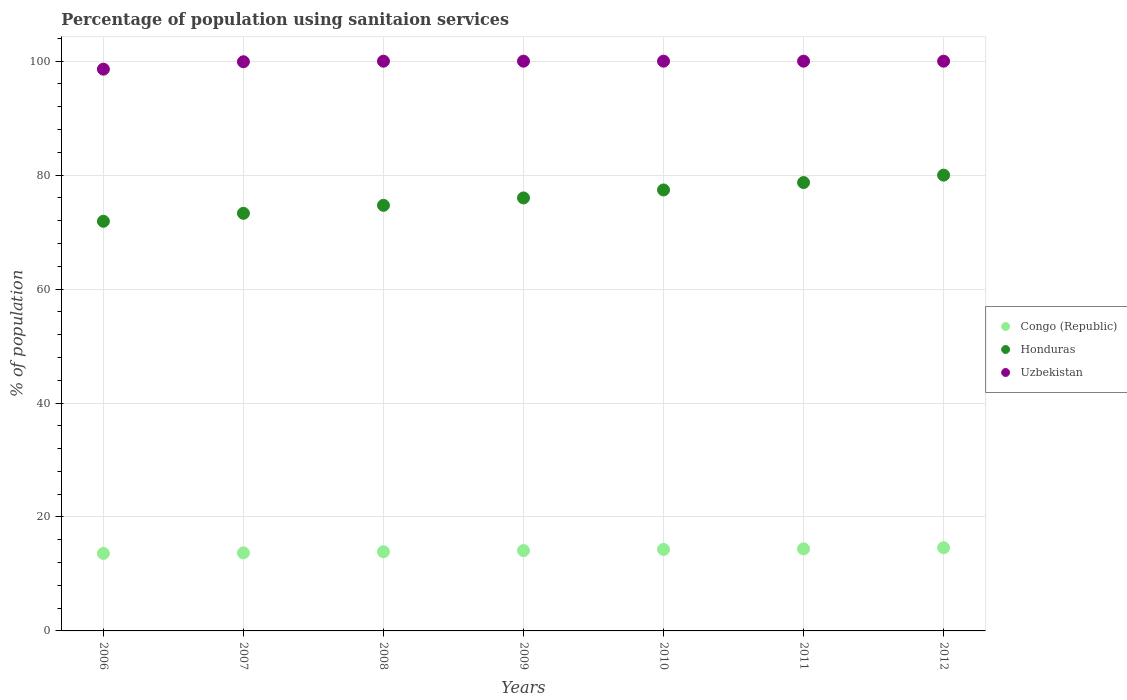How many different coloured dotlines are there?
Offer a very short reply. 3. Is the number of dotlines equal to the number of legend labels?
Your answer should be compact. Yes. Across all years, what is the minimum percentage of population using sanitaion services in Congo (Republic)?
Provide a succinct answer. 13.6. In which year was the percentage of population using sanitaion services in Uzbekistan minimum?
Provide a succinct answer. 2006. What is the total percentage of population using sanitaion services in Congo (Republic) in the graph?
Make the answer very short. 98.6. What is the difference between the percentage of population using sanitaion services in Uzbekistan in 2011 and that in 2012?
Keep it short and to the point. 0. What is the difference between the percentage of population using sanitaion services in Honduras in 2008 and the percentage of population using sanitaion services in Uzbekistan in 2009?
Offer a terse response. -25.3. What is the average percentage of population using sanitaion services in Uzbekistan per year?
Provide a short and direct response. 99.79. In the year 2010, what is the difference between the percentage of population using sanitaion services in Honduras and percentage of population using sanitaion services in Congo (Republic)?
Ensure brevity in your answer.  63.1. In how many years, is the percentage of population using sanitaion services in Honduras greater than 36 %?
Offer a very short reply. 7. Is the percentage of population using sanitaion services in Congo (Republic) in 2006 less than that in 2012?
Provide a succinct answer. Yes. Is the difference between the percentage of population using sanitaion services in Honduras in 2007 and 2008 greater than the difference between the percentage of population using sanitaion services in Congo (Republic) in 2007 and 2008?
Offer a very short reply. No. What is the difference between the highest and the second highest percentage of population using sanitaion services in Honduras?
Offer a very short reply. 1.3. What is the difference between the highest and the lowest percentage of population using sanitaion services in Honduras?
Give a very brief answer. 8.1. In how many years, is the percentage of population using sanitaion services in Uzbekistan greater than the average percentage of population using sanitaion services in Uzbekistan taken over all years?
Make the answer very short. 6. Is the percentage of population using sanitaion services in Congo (Republic) strictly greater than the percentage of population using sanitaion services in Uzbekistan over the years?
Make the answer very short. No. Is the percentage of population using sanitaion services in Honduras strictly less than the percentage of population using sanitaion services in Congo (Republic) over the years?
Keep it short and to the point. No. How many dotlines are there?
Offer a very short reply. 3. Are the values on the major ticks of Y-axis written in scientific E-notation?
Provide a short and direct response. No. Does the graph contain any zero values?
Your answer should be very brief. No. What is the title of the graph?
Your answer should be very brief. Percentage of population using sanitaion services. Does "South Sudan" appear as one of the legend labels in the graph?
Your answer should be very brief. No. What is the label or title of the X-axis?
Make the answer very short. Years. What is the label or title of the Y-axis?
Give a very brief answer. % of population. What is the % of population in Honduras in 2006?
Your answer should be compact. 71.9. What is the % of population in Uzbekistan in 2006?
Your answer should be compact. 98.6. What is the % of population of Congo (Republic) in 2007?
Your answer should be very brief. 13.7. What is the % of population in Honduras in 2007?
Your response must be concise. 73.3. What is the % of population of Uzbekistan in 2007?
Your response must be concise. 99.9. What is the % of population of Honduras in 2008?
Your answer should be compact. 74.7. What is the % of population of Honduras in 2009?
Provide a succinct answer. 76. What is the % of population of Congo (Republic) in 2010?
Your answer should be compact. 14.3. What is the % of population in Honduras in 2010?
Offer a terse response. 77.4. What is the % of population of Uzbekistan in 2010?
Ensure brevity in your answer.  100. What is the % of population of Honduras in 2011?
Give a very brief answer. 78.7. What is the % of population in Uzbekistan in 2011?
Offer a very short reply. 100. What is the % of population of Congo (Republic) in 2012?
Make the answer very short. 14.6. What is the % of population of Honduras in 2012?
Ensure brevity in your answer.  80. Across all years, what is the maximum % of population in Congo (Republic)?
Offer a terse response. 14.6. Across all years, what is the maximum % of population of Honduras?
Offer a terse response. 80. Across all years, what is the maximum % of population in Uzbekistan?
Provide a succinct answer. 100. Across all years, what is the minimum % of population in Congo (Republic)?
Provide a short and direct response. 13.6. Across all years, what is the minimum % of population in Honduras?
Offer a terse response. 71.9. Across all years, what is the minimum % of population of Uzbekistan?
Your answer should be compact. 98.6. What is the total % of population of Congo (Republic) in the graph?
Your response must be concise. 98.6. What is the total % of population of Honduras in the graph?
Your answer should be compact. 532. What is the total % of population in Uzbekistan in the graph?
Provide a short and direct response. 698.5. What is the difference between the % of population in Congo (Republic) in 2006 and that in 2007?
Your answer should be compact. -0.1. What is the difference between the % of population of Honduras in 2006 and that in 2007?
Ensure brevity in your answer.  -1.4. What is the difference between the % of population in Uzbekistan in 2006 and that in 2007?
Offer a very short reply. -1.3. What is the difference between the % of population of Congo (Republic) in 2006 and that in 2008?
Keep it short and to the point. -0.3. What is the difference between the % of population of Honduras in 2006 and that in 2008?
Ensure brevity in your answer.  -2.8. What is the difference between the % of population in Congo (Republic) in 2006 and that in 2010?
Keep it short and to the point. -0.7. What is the difference between the % of population in Honduras in 2006 and that in 2011?
Your answer should be compact. -6.8. What is the difference between the % of population of Uzbekistan in 2006 and that in 2011?
Your answer should be very brief. -1.4. What is the difference between the % of population in Uzbekistan in 2006 and that in 2012?
Give a very brief answer. -1.4. What is the difference between the % of population of Congo (Republic) in 2007 and that in 2008?
Ensure brevity in your answer.  -0.2. What is the difference between the % of population in Honduras in 2007 and that in 2008?
Ensure brevity in your answer.  -1.4. What is the difference between the % of population of Congo (Republic) in 2007 and that in 2009?
Provide a succinct answer. -0.4. What is the difference between the % of population of Uzbekistan in 2007 and that in 2009?
Offer a very short reply. -0.1. What is the difference between the % of population of Congo (Republic) in 2007 and that in 2010?
Your response must be concise. -0.6. What is the difference between the % of population of Honduras in 2007 and that in 2010?
Provide a short and direct response. -4.1. What is the difference between the % of population of Honduras in 2007 and that in 2011?
Offer a terse response. -5.4. What is the difference between the % of population in Congo (Republic) in 2007 and that in 2012?
Your response must be concise. -0.9. What is the difference between the % of population of Uzbekistan in 2007 and that in 2012?
Offer a terse response. -0.1. What is the difference between the % of population of Congo (Republic) in 2008 and that in 2009?
Offer a very short reply. -0.2. What is the difference between the % of population in Honduras in 2008 and that in 2009?
Provide a short and direct response. -1.3. What is the difference between the % of population in Uzbekistan in 2008 and that in 2009?
Give a very brief answer. 0. What is the difference between the % of population of Uzbekistan in 2008 and that in 2010?
Provide a short and direct response. 0. What is the difference between the % of population of Congo (Republic) in 2008 and that in 2011?
Your response must be concise. -0.5. What is the difference between the % of population in Honduras in 2008 and that in 2011?
Keep it short and to the point. -4. What is the difference between the % of population in Congo (Republic) in 2008 and that in 2012?
Offer a very short reply. -0.7. What is the difference between the % of population of Honduras in 2008 and that in 2012?
Your answer should be compact. -5.3. What is the difference between the % of population in Uzbekistan in 2008 and that in 2012?
Offer a very short reply. 0. What is the difference between the % of population in Congo (Republic) in 2009 and that in 2010?
Ensure brevity in your answer.  -0.2. What is the difference between the % of population in Congo (Republic) in 2009 and that in 2011?
Keep it short and to the point. -0.3. What is the difference between the % of population of Honduras in 2009 and that in 2011?
Keep it short and to the point. -2.7. What is the difference between the % of population of Congo (Republic) in 2009 and that in 2012?
Your response must be concise. -0.5. What is the difference between the % of population in Congo (Republic) in 2010 and that in 2011?
Your answer should be very brief. -0.1. What is the difference between the % of population in Honduras in 2010 and that in 2011?
Offer a very short reply. -1.3. What is the difference between the % of population of Uzbekistan in 2010 and that in 2011?
Keep it short and to the point. 0. What is the difference between the % of population of Congo (Republic) in 2010 and that in 2012?
Offer a very short reply. -0.3. What is the difference between the % of population in Honduras in 2010 and that in 2012?
Offer a terse response. -2.6. What is the difference between the % of population in Congo (Republic) in 2011 and that in 2012?
Your answer should be compact. -0.2. What is the difference between the % of population in Honduras in 2011 and that in 2012?
Ensure brevity in your answer.  -1.3. What is the difference between the % of population in Uzbekistan in 2011 and that in 2012?
Provide a succinct answer. 0. What is the difference between the % of population in Congo (Republic) in 2006 and the % of population in Honduras in 2007?
Your answer should be compact. -59.7. What is the difference between the % of population of Congo (Republic) in 2006 and the % of population of Uzbekistan in 2007?
Provide a short and direct response. -86.3. What is the difference between the % of population of Congo (Republic) in 2006 and the % of population of Honduras in 2008?
Keep it short and to the point. -61.1. What is the difference between the % of population in Congo (Republic) in 2006 and the % of population in Uzbekistan in 2008?
Provide a succinct answer. -86.4. What is the difference between the % of population in Honduras in 2006 and the % of population in Uzbekistan in 2008?
Offer a very short reply. -28.1. What is the difference between the % of population of Congo (Republic) in 2006 and the % of population of Honduras in 2009?
Make the answer very short. -62.4. What is the difference between the % of population of Congo (Republic) in 2006 and the % of population of Uzbekistan in 2009?
Ensure brevity in your answer.  -86.4. What is the difference between the % of population of Honduras in 2006 and the % of population of Uzbekistan in 2009?
Offer a very short reply. -28.1. What is the difference between the % of population in Congo (Republic) in 2006 and the % of population in Honduras in 2010?
Ensure brevity in your answer.  -63.8. What is the difference between the % of population of Congo (Republic) in 2006 and the % of population of Uzbekistan in 2010?
Your answer should be compact. -86.4. What is the difference between the % of population in Honduras in 2006 and the % of population in Uzbekistan in 2010?
Give a very brief answer. -28.1. What is the difference between the % of population of Congo (Republic) in 2006 and the % of population of Honduras in 2011?
Your response must be concise. -65.1. What is the difference between the % of population in Congo (Republic) in 2006 and the % of population in Uzbekistan in 2011?
Your response must be concise. -86.4. What is the difference between the % of population in Honduras in 2006 and the % of population in Uzbekistan in 2011?
Keep it short and to the point. -28.1. What is the difference between the % of population of Congo (Republic) in 2006 and the % of population of Honduras in 2012?
Provide a succinct answer. -66.4. What is the difference between the % of population in Congo (Republic) in 2006 and the % of population in Uzbekistan in 2012?
Provide a short and direct response. -86.4. What is the difference between the % of population of Honduras in 2006 and the % of population of Uzbekistan in 2012?
Your answer should be compact. -28.1. What is the difference between the % of population in Congo (Republic) in 2007 and the % of population in Honduras in 2008?
Your response must be concise. -61. What is the difference between the % of population of Congo (Republic) in 2007 and the % of population of Uzbekistan in 2008?
Make the answer very short. -86.3. What is the difference between the % of population of Honduras in 2007 and the % of population of Uzbekistan in 2008?
Provide a short and direct response. -26.7. What is the difference between the % of population in Congo (Republic) in 2007 and the % of population in Honduras in 2009?
Your response must be concise. -62.3. What is the difference between the % of population of Congo (Republic) in 2007 and the % of population of Uzbekistan in 2009?
Make the answer very short. -86.3. What is the difference between the % of population of Honduras in 2007 and the % of population of Uzbekistan in 2009?
Keep it short and to the point. -26.7. What is the difference between the % of population in Congo (Republic) in 2007 and the % of population in Honduras in 2010?
Your response must be concise. -63.7. What is the difference between the % of population of Congo (Republic) in 2007 and the % of population of Uzbekistan in 2010?
Provide a short and direct response. -86.3. What is the difference between the % of population of Honduras in 2007 and the % of population of Uzbekistan in 2010?
Make the answer very short. -26.7. What is the difference between the % of population of Congo (Republic) in 2007 and the % of population of Honduras in 2011?
Ensure brevity in your answer.  -65. What is the difference between the % of population in Congo (Republic) in 2007 and the % of population in Uzbekistan in 2011?
Provide a short and direct response. -86.3. What is the difference between the % of population in Honduras in 2007 and the % of population in Uzbekistan in 2011?
Make the answer very short. -26.7. What is the difference between the % of population of Congo (Republic) in 2007 and the % of population of Honduras in 2012?
Make the answer very short. -66.3. What is the difference between the % of population of Congo (Republic) in 2007 and the % of population of Uzbekistan in 2012?
Ensure brevity in your answer.  -86.3. What is the difference between the % of population of Honduras in 2007 and the % of population of Uzbekistan in 2012?
Keep it short and to the point. -26.7. What is the difference between the % of population in Congo (Republic) in 2008 and the % of population in Honduras in 2009?
Your answer should be very brief. -62.1. What is the difference between the % of population of Congo (Republic) in 2008 and the % of population of Uzbekistan in 2009?
Offer a very short reply. -86.1. What is the difference between the % of population in Honduras in 2008 and the % of population in Uzbekistan in 2009?
Provide a succinct answer. -25.3. What is the difference between the % of population of Congo (Republic) in 2008 and the % of population of Honduras in 2010?
Offer a terse response. -63.5. What is the difference between the % of population in Congo (Republic) in 2008 and the % of population in Uzbekistan in 2010?
Offer a terse response. -86.1. What is the difference between the % of population in Honduras in 2008 and the % of population in Uzbekistan in 2010?
Ensure brevity in your answer.  -25.3. What is the difference between the % of population in Congo (Republic) in 2008 and the % of population in Honduras in 2011?
Give a very brief answer. -64.8. What is the difference between the % of population in Congo (Republic) in 2008 and the % of population in Uzbekistan in 2011?
Give a very brief answer. -86.1. What is the difference between the % of population in Honduras in 2008 and the % of population in Uzbekistan in 2011?
Keep it short and to the point. -25.3. What is the difference between the % of population of Congo (Republic) in 2008 and the % of population of Honduras in 2012?
Ensure brevity in your answer.  -66.1. What is the difference between the % of population of Congo (Republic) in 2008 and the % of population of Uzbekistan in 2012?
Ensure brevity in your answer.  -86.1. What is the difference between the % of population of Honduras in 2008 and the % of population of Uzbekistan in 2012?
Keep it short and to the point. -25.3. What is the difference between the % of population of Congo (Republic) in 2009 and the % of population of Honduras in 2010?
Your response must be concise. -63.3. What is the difference between the % of population of Congo (Republic) in 2009 and the % of population of Uzbekistan in 2010?
Offer a terse response. -85.9. What is the difference between the % of population of Honduras in 2009 and the % of population of Uzbekistan in 2010?
Offer a terse response. -24. What is the difference between the % of population of Congo (Republic) in 2009 and the % of population of Honduras in 2011?
Provide a short and direct response. -64.6. What is the difference between the % of population in Congo (Republic) in 2009 and the % of population in Uzbekistan in 2011?
Offer a very short reply. -85.9. What is the difference between the % of population in Honduras in 2009 and the % of population in Uzbekistan in 2011?
Make the answer very short. -24. What is the difference between the % of population of Congo (Republic) in 2009 and the % of population of Honduras in 2012?
Your answer should be very brief. -65.9. What is the difference between the % of population in Congo (Republic) in 2009 and the % of population in Uzbekistan in 2012?
Make the answer very short. -85.9. What is the difference between the % of population in Honduras in 2009 and the % of population in Uzbekistan in 2012?
Provide a succinct answer. -24. What is the difference between the % of population in Congo (Republic) in 2010 and the % of population in Honduras in 2011?
Give a very brief answer. -64.4. What is the difference between the % of population in Congo (Republic) in 2010 and the % of population in Uzbekistan in 2011?
Your response must be concise. -85.7. What is the difference between the % of population of Honduras in 2010 and the % of population of Uzbekistan in 2011?
Your answer should be compact. -22.6. What is the difference between the % of population in Congo (Republic) in 2010 and the % of population in Honduras in 2012?
Provide a succinct answer. -65.7. What is the difference between the % of population in Congo (Republic) in 2010 and the % of population in Uzbekistan in 2012?
Keep it short and to the point. -85.7. What is the difference between the % of population of Honduras in 2010 and the % of population of Uzbekistan in 2012?
Keep it short and to the point. -22.6. What is the difference between the % of population in Congo (Republic) in 2011 and the % of population in Honduras in 2012?
Keep it short and to the point. -65.6. What is the difference between the % of population of Congo (Republic) in 2011 and the % of population of Uzbekistan in 2012?
Your response must be concise. -85.6. What is the difference between the % of population of Honduras in 2011 and the % of population of Uzbekistan in 2012?
Provide a short and direct response. -21.3. What is the average % of population of Congo (Republic) per year?
Ensure brevity in your answer.  14.09. What is the average % of population in Honduras per year?
Offer a very short reply. 76. What is the average % of population of Uzbekistan per year?
Your answer should be compact. 99.79. In the year 2006, what is the difference between the % of population of Congo (Republic) and % of population of Honduras?
Keep it short and to the point. -58.3. In the year 2006, what is the difference between the % of population of Congo (Republic) and % of population of Uzbekistan?
Offer a very short reply. -85. In the year 2006, what is the difference between the % of population in Honduras and % of population in Uzbekistan?
Your answer should be compact. -26.7. In the year 2007, what is the difference between the % of population of Congo (Republic) and % of population of Honduras?
Give a very brief answer. -59.6. In the year 2007, what is the difference between the % of population in Congo (Republic) and % of population in Uzbekistan?
Offer a terse response. -86.2. In the year 2007, what is the difference between the % of population in Honduras and % of population in Uzbekistan?
Provide a short and direct response. -26.6. In the year 2008, what is the difference between the % of population of Congo (Republic) and % of population of Honduras?
Give a very brief answer. -60.8. In the year 2008, what is the difference between the % of population of Congo (Republic) and % of population of Uzbekistan?
Provide a succinct answer. -86.1. In the year 2008, what is the difference between the % of population in Honduras and % of population in Uzbekistan?
Offer a very short reply. -25.3. In the year 2009, what is the difference between the % of population of Congo (Republic) and % of population of Honduras?
Keep it short and to the point. -61.9. In the year 2009, what is the difference between the % of population of Congo (Republic) and % of population of Uzbekistan?
Offer a very short reply. -85.9. In the year 2009, what is the difference between the % of population of Honduras and % of population of Uzbekistan?
Your answer should be very brief. -24. In the year 2010, what is the difference between the % of population of Congo (Republic) and % of population of Honduras?
Your answer should be compact. -63.1. In the year 2010, what is the difference between the % of population in Congo (Republic) and % of population in Uzbekistan?
Give a very brief answer. -85.7. In the year 2010, what is the difference between the % of population in Honduras and % of population in Uzbekistan?
Offer a very short reply. -22.6. In the year 2011, what is the difference between the % of population of Congo (Republic) and % of population of Honduras?
Your response must be concise. -64.3. In the year 2011, what is the difference between the % of population in Congo (Republic) and % of population in Uzbekistan?
Give a very brief answer. -85.6. In the year 2011, what is the difference between the % of population of Honduras and % of population of Uzbekistan?
Offer a very short reply. -21.3. In the year 2012, what is the difference between the % of population in Congo (Republic) and % of population in Honduras?
Give a very brief answer. -65.4. In the year 2012, what is the difference between the % of population of Congo (Republic) and % of population of Uzbekistan?
Give a very brief answer. -85.4. In the year 2012, what is the difference between the % of population of Honduras and % of population of Uzbekistan?
Provide a short and direct response. -20. What is the ratio of the % of population in Congo (Republic) in 2006 to that in 2007?
Give a very brief answer. 0.99. What is the ratio of the % of population in Honduras in 2006 to that in 2007?
Your answer should be compact. 0.98. What is the ratio of the % of population in Uzbekistan in 2006 to that in 2007?
Your answer should be very brief. 0.99. What is the ratio of the % of population in Congo (Republic) in 2006 to that in 2008?
Your answer should be compact. 0.98. What is the ratio of the % of population in Honduras in 2006 to that in 2008?
Give a very brief answer. 0.96. What is the ratio of the % of population of Uzbekistan in 2006 to that in 2008?
Make the answer very short. 0.99. What is the ratio of the % of population in Congo (Republic) in 2006 to that in 2009?
Make the answer very short. 0.96. What is the ratio of the % of population in Honduras in 2006 to that in 2009?
Give a very brief answer. 0.95. What is the ratio of the % of population in Congo (Republic) in 2006 to that in 2010?
Your answer should be compact. 0.95. What is the ratio of the % of population in Honduras in 2006 to that in 2010?
Keep it short and to the point. 0.93. What is the ratio of the % of population in Uzbekistan in 2006 to that in 2010?
Offer a terse response. 0.99. What is the ratio of the % of population in Congo (Republic) in 2006 to that in 2011?
Your response must be concise. 0.94. What is the ratio of the % of population of Honduras in 2006 to that in 2011?
Keep it short and to the point. 0.91. What is the ratio of the % of population in Congo (Republic) in 2006 to that in 2012?
Give a very brief answer. 0.93. What is the ratio of the % of population of Honduras in 2006 to that in 2012?
Offer a very short reply. 0.9. What is the ratio of the % of population in Uzbekistan in 2006 to that in 2012?
Your response must be concise. 0.99. What is the ratio of the % of population in Congo (Republic) in 2007 to that in 2008?
Make the answer very short. 0.99. What is the ratio of the % of population in Honduras in 2007 to that in 2008?
Provide a succinct answer. 0.98. What is the ratio of the % of population in Uzbekistan in 2007 to that in 2008?
Make the answer very short. 1. What is the ratio of the % of population in Congo (Republic) in 2007 to that in 2009?
Your response must be concise. 0.97. What is the ratio of the % of population of Honduras in 2007 to that in 2009?
Your response must be concise. 0.96. What is the ratio of the % of population of Uzbekistan in 2007 to that in 2009?
Offer a very short reply. 1. What is the ratio of the % of population in Congo (Republic) in 2007 to that in 2010?
Give a very brief answer. 0.96. What is the ratio of the % of population of Honduras in 2007 to that in 2010?
Keep it short and to the point. 0.95. What is the ratio of the % of population in Uzbekistan in 2007 to that in 2010?
Provide a short and direct response. 1. What is the ratio of the % of population in Congo (Republic) in 2007 to that in 2011?
Keep it short and to the point. 0.95. What is the ratio of the % of population in Honduras in 2007 to that in 2011?
Ensure brevity in your answer.  0.93. What is the ratio of the % of population in Uzbekistan in 2007 to that in 2011?
Offer a terse response. 1. What is the ratio of the % of population in Congo (Republic) in 2007 to that in 2012?
Ensure brevity in your answer.  0.94. What is the ratio of the % of population of Honduras in 2007 to that in 2012?
Your response must be concise. 0.92. What is the ratio of the % of population of Uzbekistan in 2007 to that in 2012?
Offer a terse response. 1. What is the ratio of the % of population in Congo (Republic) in 2008 to that in 2009?
Offer a very short reply. 0.99. What is the ratio of the % of population in Honduras in 2008 to that in 2009?
Your answer should be compact. 0.98. What is the ratio of the % of population in Congo (Republic) in 2008 to that in 2010?
Your answer should be very brief. 0.97. What is the ratio of the % of population in Honduras in 2008 to that in 2010?
Provide a short and direct response. 0.97. What is the ratio of the % of population of Uzbekistan in 2008 to that in 2010?
Make the answer very short. 1. What is the ratio of the % of population of Congo (Republic) in 2008 to that in 2011?
Provide a short and direct response. 0.97. What is the ratio of the % of population in Honduras in 2008 to that in 2011?
Your answer should be compact. 0.95. What is the ratio of the % of population of Uzbekistan in 2008 to that in 2011?
Make the answer very short. 1. What is the ratio of the % of population of Congo (Republic) in 2008 to that in 2012?
Your answer should be very brief. 0.95. What is the ratio of the % of population in Honduras in 2008 to that in 2012?
Your answer should be very brief. 0.93. What is the ratio of the % of population in Uzbekistan in 2008 to that in 2012?
Provide a succinct answer. 1. What is the ratio of the % of population in Honduras in 2009 to that in 2010?
Give a very brief answer. 0.98. What is the ratio of the % of population of Uzbekistan in 2009 to that in 2010?
Your answer should be very brief. 1. What is the ratio of the % of population of Congo (Republic) in 2009 to that in 2011?
Your answer should be very brief. 0.98. What is the ratio of the % of population of Honduras in 2009 to that in 2011?
Keep it short and to the point. 0.97. What is the ratio of the % of population of Congo (Republic) in 2009 to that in 2012?
Provide a short and direct response. 0.97. What is the ratio of the % of population in Honduras in 2009 to that in 2012?
Offer a terse response. 0.95. What is the ratio of the % of population in Congo (Republic) in 2010 to that in 2011?
Your answer should be compact. 0.99. What is the ratio of the % of population of Honduras in 2010 to that in 2011?
Provide a short and direct response. 0.98. What is the ratio of the % of population in Congo (Republic) in 2010 to that in 2012?
Make the answer very short. 0.98. What is the ratio of the % of population in Honduras in 2010 to that in 2012?
Your answer should be compact. 0.97. What is the ratio of the % of population of Uzbekistan in 2010 to that in 2012?
Keep it short and to the point. 1. What is the ratio of the % of population of Congo (Republic) in 2011 to that in 2012?
Provide a succinct answer. 0.99. What is the ratio of the % of population in Honduras in 2011 to that in 2012?
Offer a very short reply. 0.98. What is the difference between the highest and the second highest % of population in Congo (Republic)?
Offer a very short reply. 0.2. What is the difference between the highest and the second highest % of population in Honduras?
Your answer should be compact. 1.3. What is the difference between the highest and the lowest % of population in Honduras?
Provide a short and direct response. 8.1. What is the difference between the highest and the lowest % of population of Uzbekistan?
Your answer should be compact. 1.4. 